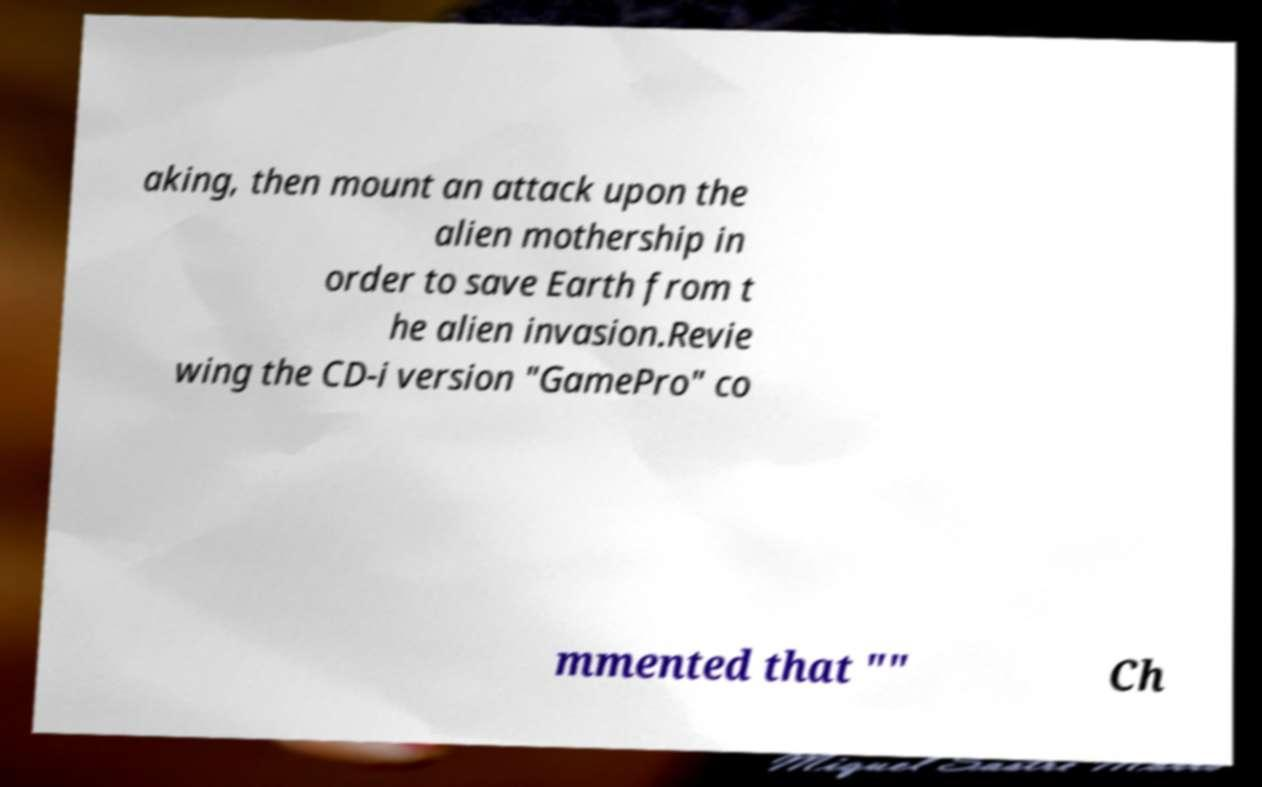Please read and relay the text visible in this image. What does it say? aking, then mount an attack upon the alien mothership in order to save Earth from t he alien invasion.Revie wing the CD-i version "GamePro" co mmented that "" Ch 